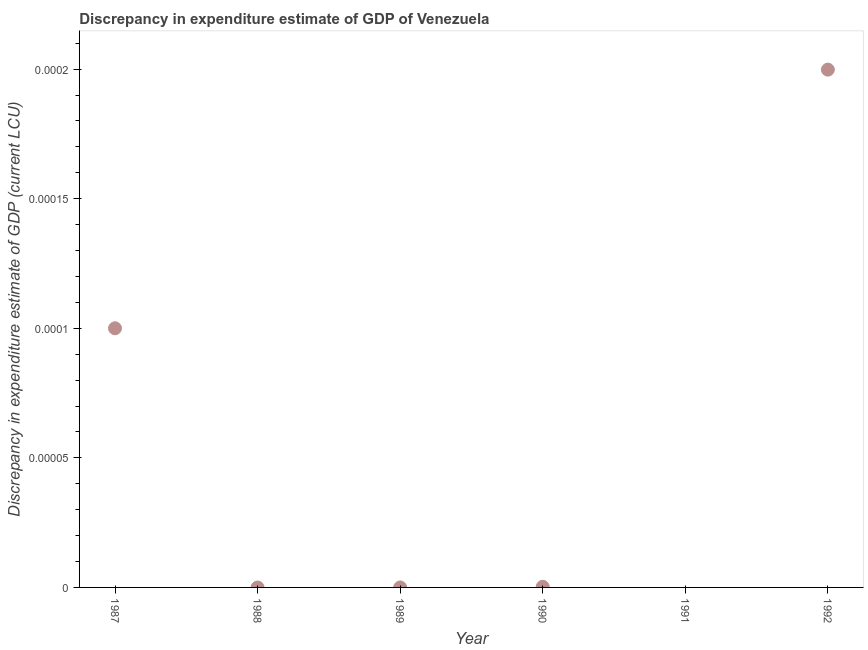What is the discrepancy in expenditure estimate of gdp in 1989?
Your answer should be compact. 0. Across all years, what is the maximum discrepancy in expenditure estimate of gdp?
Provide a short and direct response. 0. Across all years, what is the minimum discrepancy in expenditure estimate of gdp?
Keep it short and to the point. 0. In which year was the discrepancy in expenditure estimate of gdp maximum?
Make the answer very short. 1992. What is the sum of the discrepancy in expenditure estimate of gdp?
Give a very brief answer. 0. What is the difference between the discrepancy in expenditure estimate of gdp in 1987 and 1990?
Offer a very short reply. 9.975099999999999e-5. What is the average discrepancy in expenditure estimate of gdp per year?
Keep it short and to the point. 5.001016666666667e-5. What is the median discrepancy in expenditure estimate of gdp?
Offer a very short reply. 1.25e-7. What is the difference between the highest and the second highest discrepancy in expenditure estimate of gdp?
Provide a succinct answer. 9.9809e-5. What is the difference between the highest and the lowest discrepancy in expenditure estimate of gdp?
Provide a succinct answer. 0. In how many years, is the discrepancy in expenditure estimate of gdp greater than the average discrepancy in expenditure estimate of gdp taken over all years?
Give a very brief answer. 2. How many dotlines are there?
Provide a short and direct response. 1. What is the difference between two consecutive major ticks on the Y-axis?
Make the answer very short. 5e-5. Does the graph contain grids?
Give a very brief answer. No. What is the title of the graph?
Ensure brevity in your answer.  Discrepancy in expenditure estimate of GDP of Venezuela. What is the label or title of the X-axis?
Keep it short and to the point. Year. What is the label or title of the Y-axis?
Make the answer very short. Discrepancy in expenditure estimate of GDP (current LCU). What is the Discrepancy in expenditure estimate of GDP (current LCU) in 1987?
Keep it short and to the point. 0. What is the Discrepancy in expenditure estimate of GDP (current LCU) in 1988?
Offer a terse response. 0. What is the Discrepancy in expenditure estimate of GDP (current LCU) in 1989?
Make the answer very short. 0. What is the Discrepancy in expenditure estimate of GDP (current LCU) in 1990?
Your response must be concise. 2.5e-7. What is the Discrepancy in expenditure estimate of GDP (current LCU) in 1991?
Your answer should be compact. 0. What is the Discrepancy in expenditure estimate of GDP (current LCU) in 1992?
Ensure brevity in your answer.  0. What is the difference between the Discrepancy in expenditure estimate of GDP (current LCU) in 1987 and 1990?
Provide a succinct answer. 0. What is the difference between the Discrepancy in expenditure estimate of GDP (current LCU) in 1987 and 1992?
Make the answer very short. -0. What is the difference between the Discrepancy in expenditure estimate of GDP (current LCU) in 1990 and 1992?
Keep it short and to the point. -0. What is the ratio of the Discrepancy in expenditure estimate of GDP (current LCU) in 1987 to that in 1990?
Provide a succinct answer. 400. What is the ratio of the Discrepancy in expenditure estimate of GDP (current LCU) in 1990 to that in 1992?
Your answer should be compact. 0. 